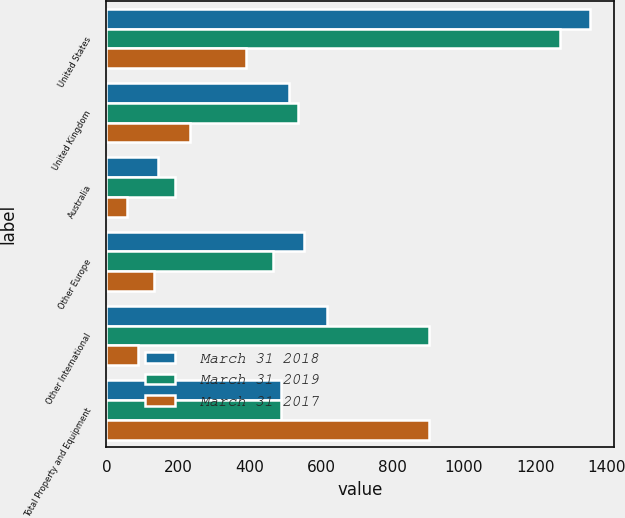Convert chart. <chart><loc_0><loc_0><loc_500><loc_500><stacked_bar_chart><ecel><fcel>United States<fcel>United Kingdom<fcel>Australia<fcel>Other Europe<fcel>Other International<fcel>Total Property and Equipment<nl><fcel>March 31 2018<fcel>1352<fcel>512<fcel>144<fcel>553<fcel>618<fcel>488.5<nl><fcel>March 31 2019<fcel>1270<fcel>535<fcel>191<fcel>465<fcel>902<fcel>488.5<nl><fcel>March 31 2017<fcel>389<fcel>235<fcel>58<fcel>134<fcel>87<fcel>903<nl></chart> 